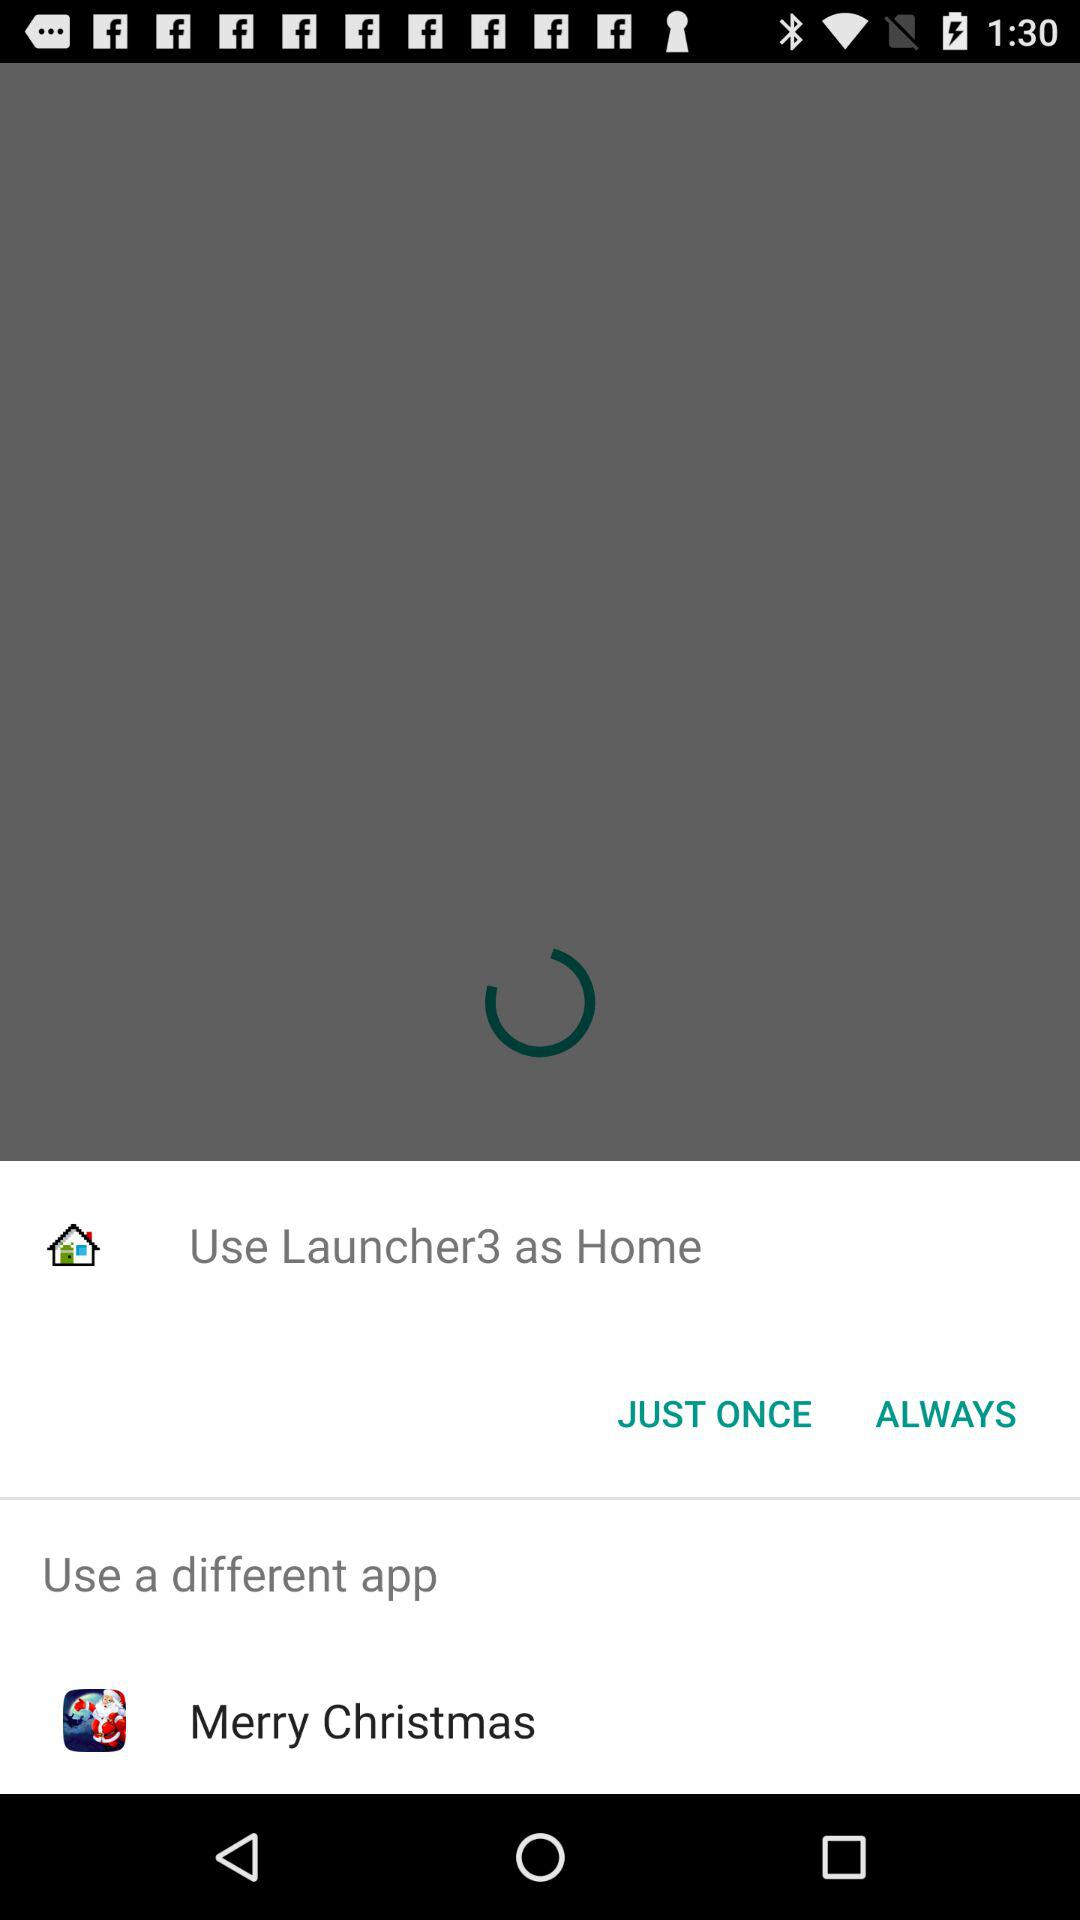What is the different application that can be used? The different application that can be used is "Merry Christmas". 